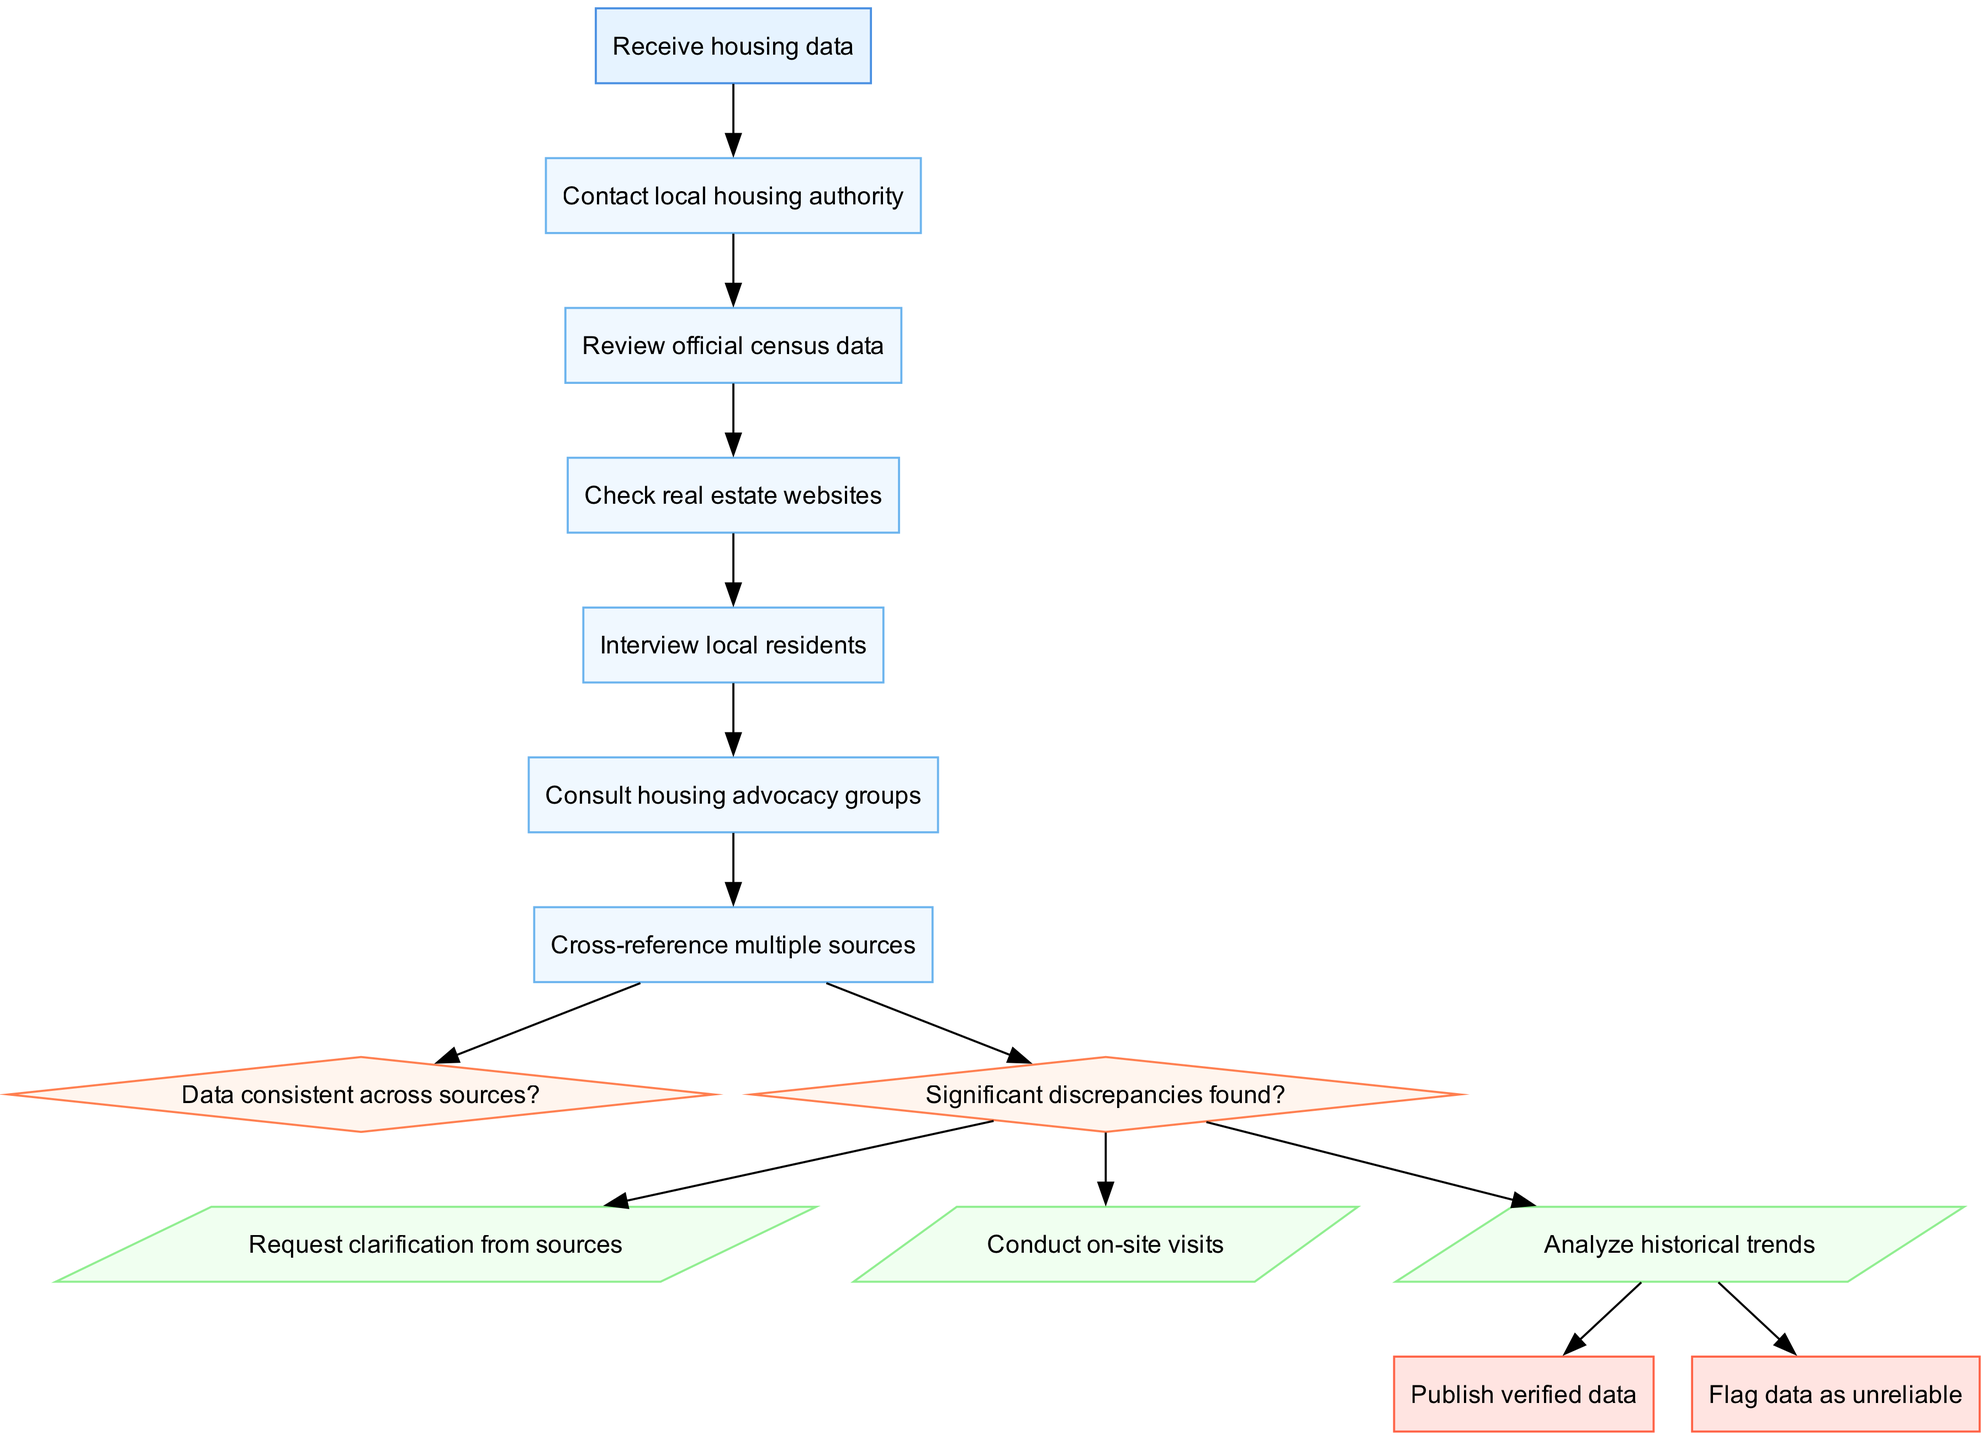What is the first step in the housing data verification process? The first step in the process is labeled "Receive housing data," and it is the starting point of the flow chart.
Answer: Receive housing data How many decisions are present in the diagram? The diagram includes two decision nodes, which address the consistency and discrepancies of the data.
Answer: 2 What action follows the decision point regarding significant discrepancies? Following the decision point about significant discrepancies, if discrepancies are found, the action requested is to "Request clarification from sources."
Answer: Request clarification from sources If data is consistent, what is the end node that follows? If data is deemed consistent, the flow proceeds towards publishing the verified data as the end point.
Answer: Publish verified data What action appears after consulting housing advocacy groups? After consulting housing advocacy groups, the next step is to "Cross-reference multiple sources," which connects the processes together in the flow.
Answer: Cross-reference multiple sources What shape represents the decision points in the diagram? The decision points in the flow chart are represented by diamonds, which is distinctive for indicating a decision-making step.
Answer: Diamond What is the last action taken before reaching the end nodes? The last action taken before reaching the end nodes is to "Analyze historical trends," which informs the final outcome of the verification process.
Answer: Analyze historical trends If there are discrepancies found, what action is taken next? If discrepancies are found, the next action taken is to "Conduct on-site visits," which implies a deeper investigation into the housing data.
Answer: Conduct on-site visits How are the processes connected to the start node? All processes are sequentially connected to the start node by directed edges, allowing a clear flow from one process to the next starting from "Receive housing data."
Answer: Directed edges 